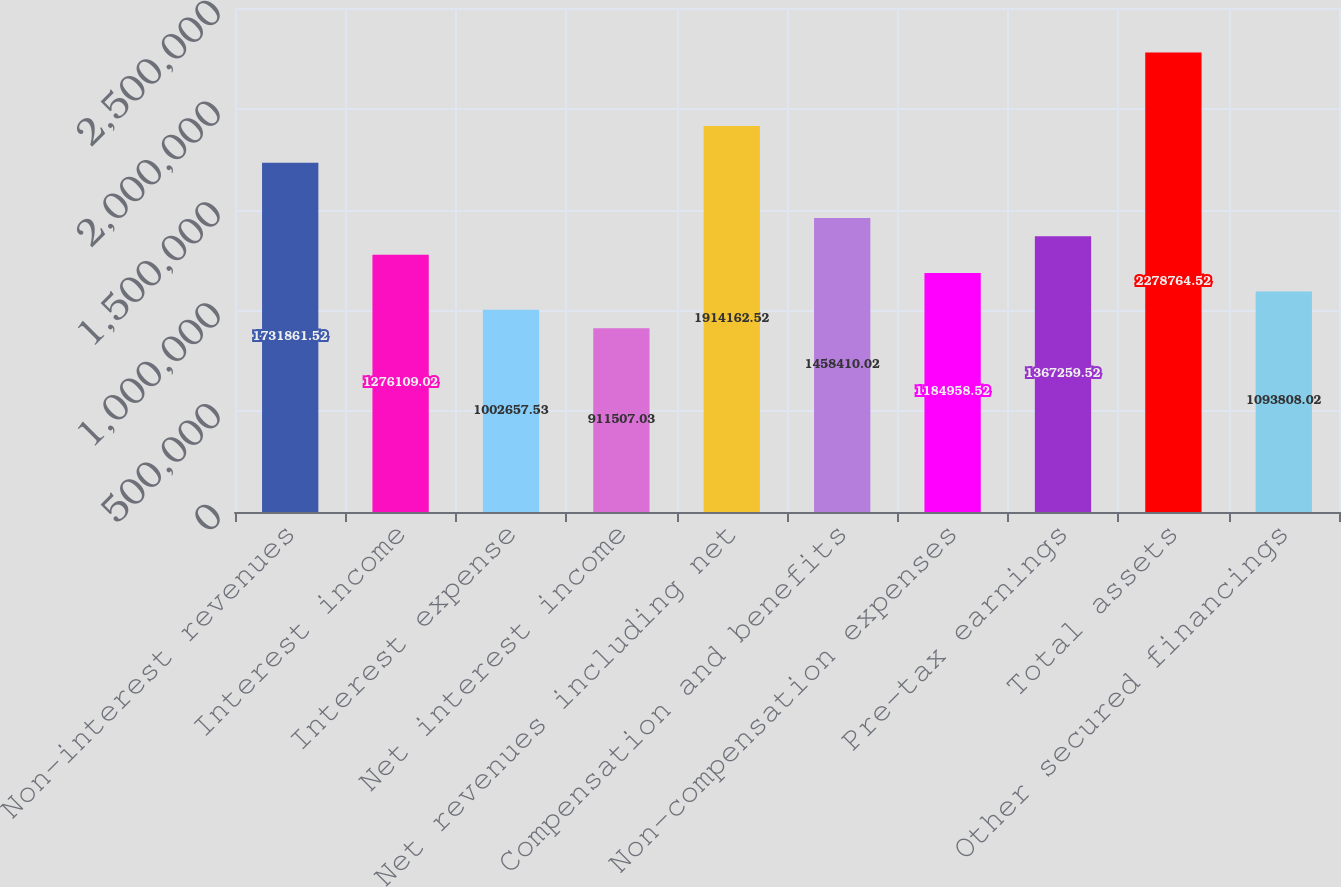Convert chart. <chart><loc_0><loc_0><loc_500><loc_500><bar_chart><fcel>Non-interest revenues<fcel>Interest income<fcel>Interest expense<fcel>Net interest income<fcel>Net revenues including net<fcel>Compensation and benefits<fcel>Non-compensation expenses<fcel>Pre-tax earnings<fcel>Total assets<fcel>Other secured financings<nl><fcel>1.73186e+06<fcel>1.27611e+06<fcel>1.00266e+06<fcel>911507<fcel>1.91416e+06<fcel>1.45841e+06<fcel>1.18496e+06<fcel>1.36726e+06<fcel>2.27876e+06<fcel>1.09381e+06<nl></chart> 